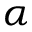Convert formula to latex. <formula><loc_0><loc_0><loc_500><loc_500>\alpha</formula> 